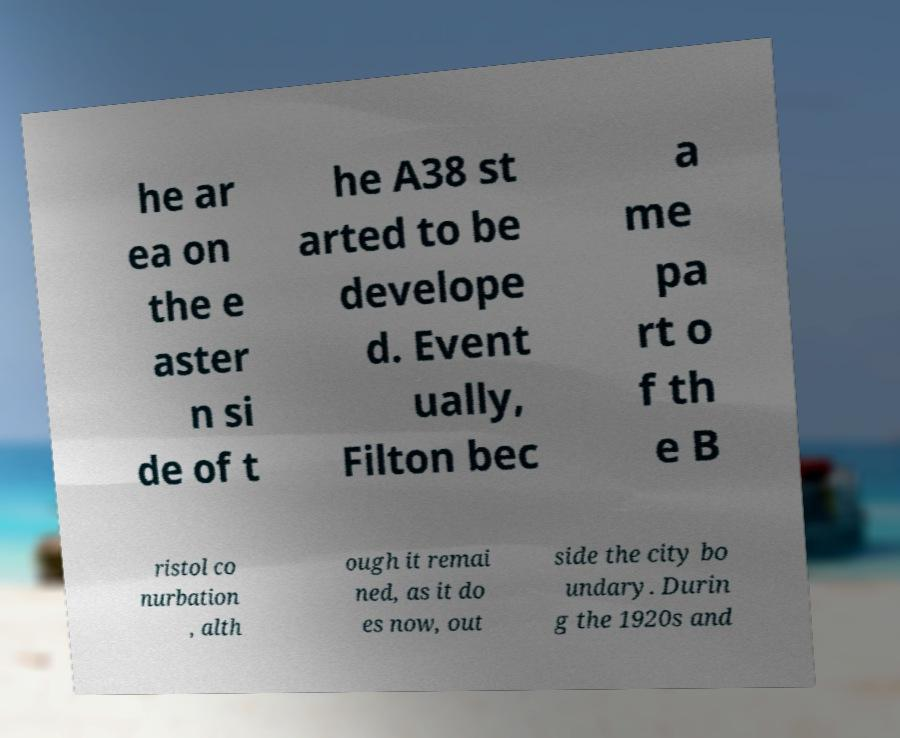Please identify and transcribe the text found in this image. he ar ea on the e aster n si de of t he A38 st arted to be develope d. Event ually, Filton bec a me pa rt o f th e B ristol co nurbation , alth ough it remai ned, as it do es now, out side the city bo undary. Durin g the 1920s and 